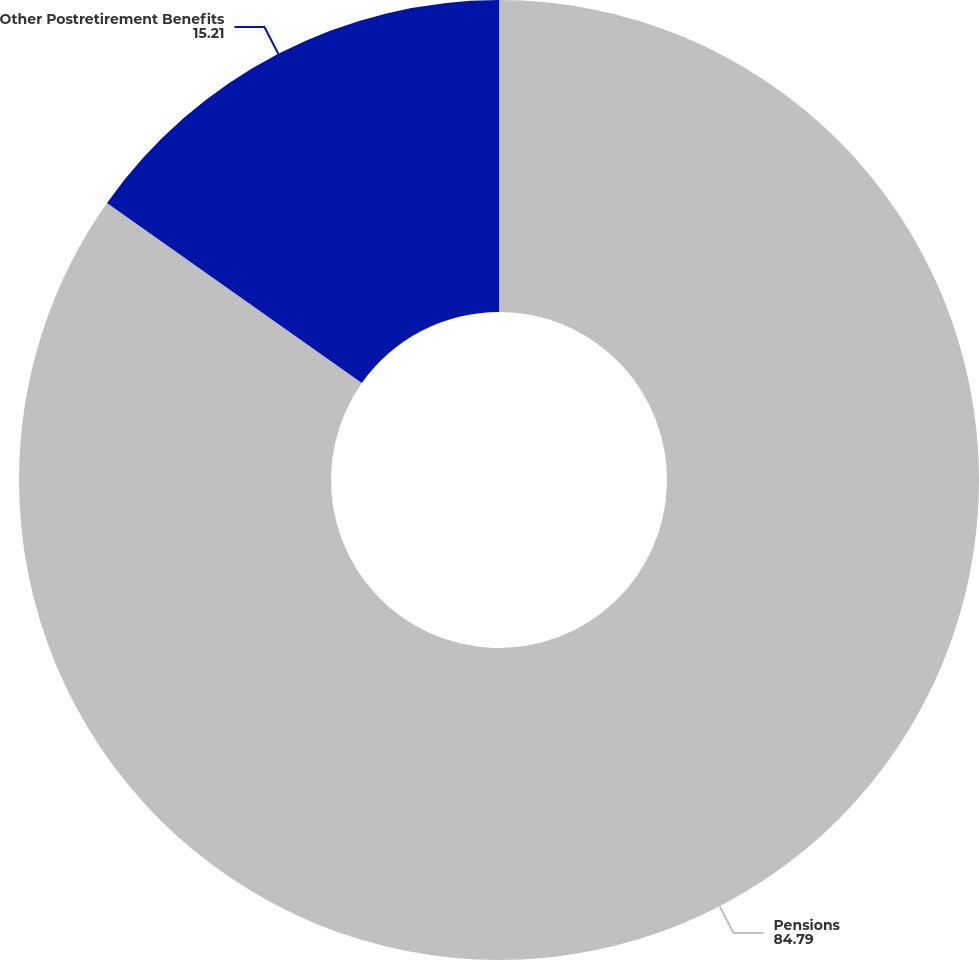<chart> <loc_0><loc_0><loc_500><loc_500><pie_chart><fcel>Pensions<fcel>Other Postretirement Benefits<nl><fcel>84.79%<fcel>15.21%<nl></chart> 